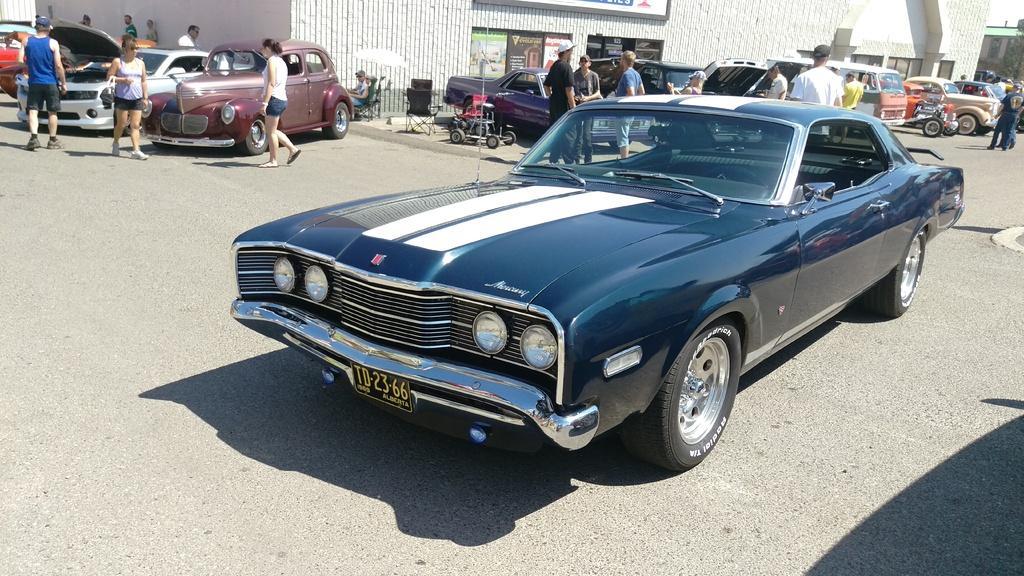Describe this image in one or two sentences. In this image there are cars on a road and people are walking on the road, in the background there is a shop. 